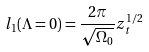<formula> <loc_0><loc_0><loc_500><loc_500>l _ { 1 } ( \Lambda = 0 ) = \frac { 2 \pi } { \sqrt { \Omega _ { 0 } } } z _ { t } ^ { 1 / 2 }</formula> 